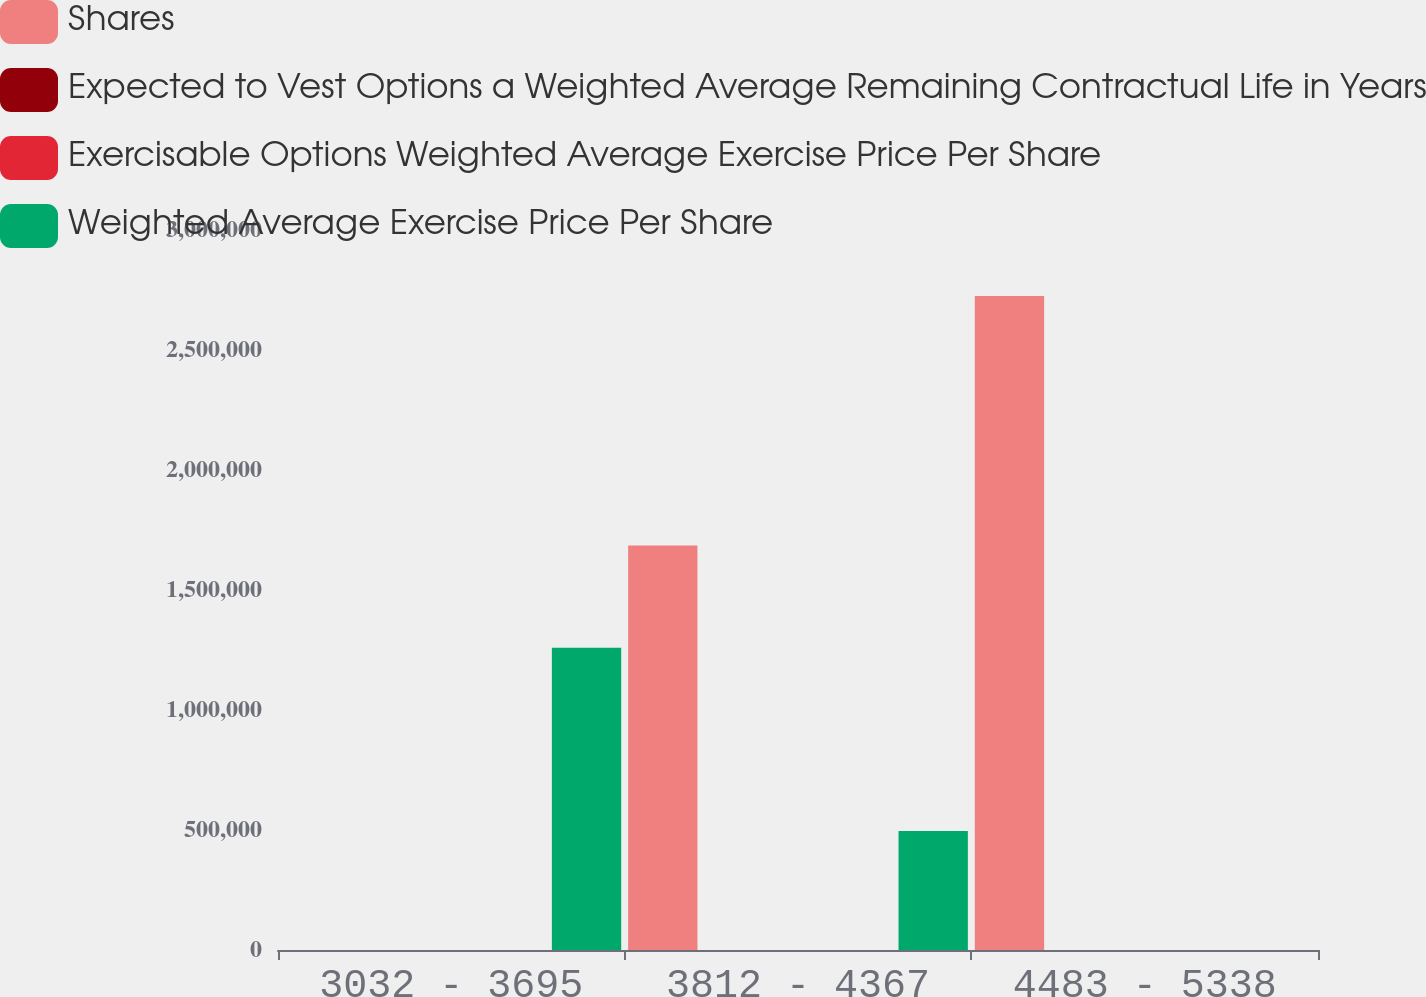Convert chart. <chart><loc_0><loc_0><loc_500><loc_500><stacked_bar_chart><ecel><fcel>3032 - 3695<fcel>3812 - 4367<fcel>4483 - 5338<nl><fcel>Shares<fcel>53.36<fcel>1.68535e+06<fcel>2.72452e+06<nl><fcel>Expected to Vest Options a Weighted Average Remaining Contractual Life in Years<fcel>35.14<fcel>43.56<fcel>53.36<nl><fcel>Exercisable Options Weighted Average Exercise Price Per Share<fcel>2.4<fcel>2.1<fcel>4<nl><fcel>Weighted Average Exercise Price Per Share<fcel>1.25945e+06<fcel>496175<fcel>500<nl></chart> 